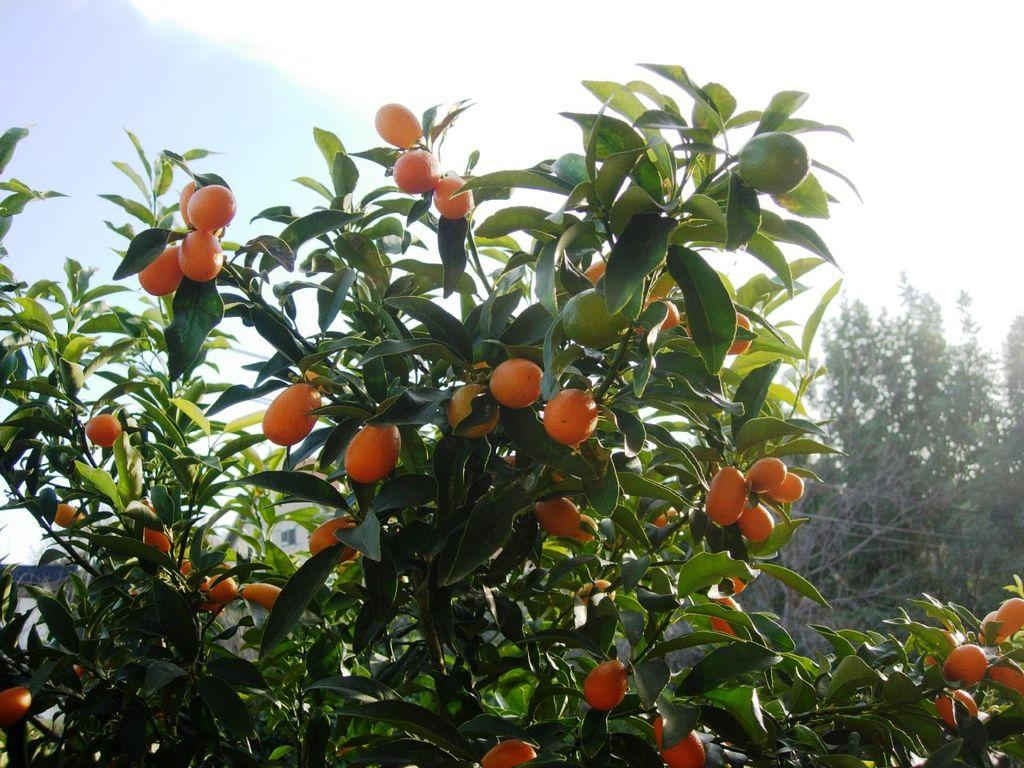What type of fruit can be seen on the plant in the image? There are many red tomatoes on the plant in the image. What else can be seen at the base of the plant? There are leaves at the bottom of the plant in the image. What is visible on the right side of the image? There are trees visible on the right side of the image. What is visible at the top of the image? The sky is visible at the top of the image. What can be seen in the sky? Clouds are present in the sky. What type of picture is being taught in the image? There is no picture being taught in the image; it features a tomato plant with red tomatoes and leaves. How are the tomatoes being washed in the image? The tomatoes are not being washed in the image; they are on the plant and not being handled or manipulated. 